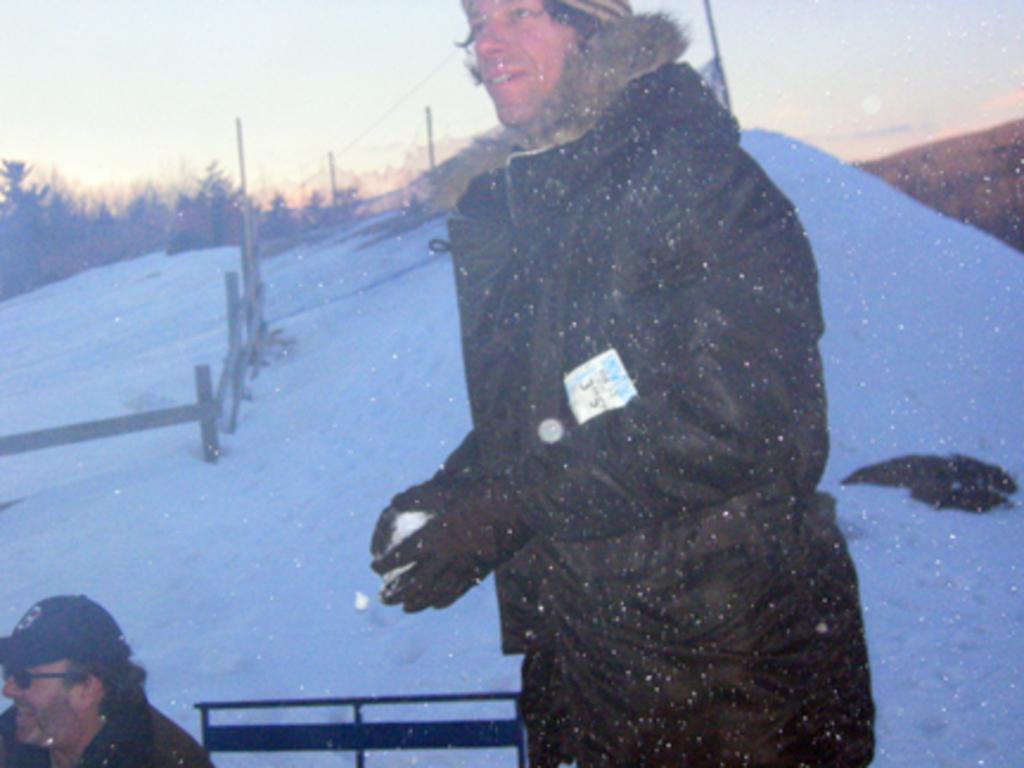How would you summarize this image in a sentence or two? This image is taken outdoors. At the bottom of the image there is snow. In the middle of the image there is a man and he is playing with snow. On the left side of the image there is a man and there is a fencing. In the background there are a few trees and plants. At the top of the image there is a sky. 